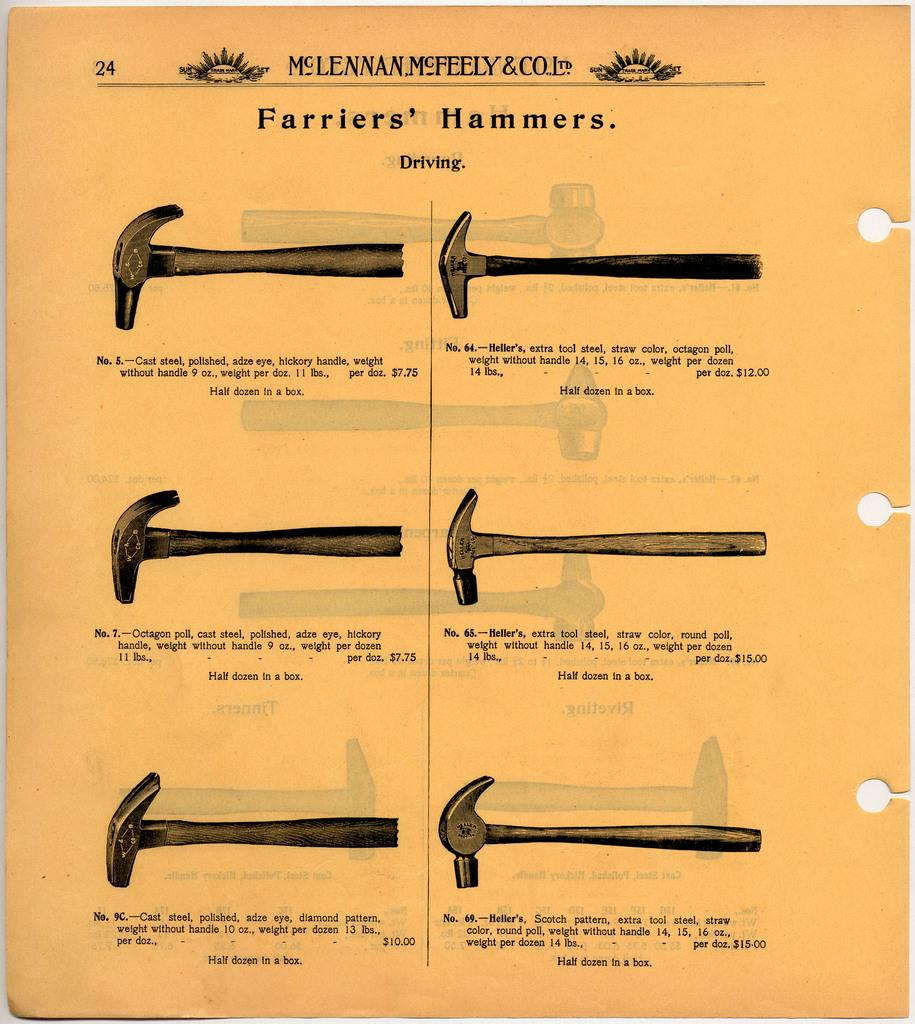What is present in the image that is related to drawing or writing? There is a paper in the image. What is depicted on the paper? The paper contains different shapes of hammers. Is there any text on the paper? Yes, there is text on the paper. What type of liquid can be seen flowing from the hammers in the image? There is no liquid present in the image; it features a paper with different shapes of hammers and text. How does the behavior of the hammers change throughout the image? The image does not depict any behavior of the hammers, as they are static shapes on a paper. 